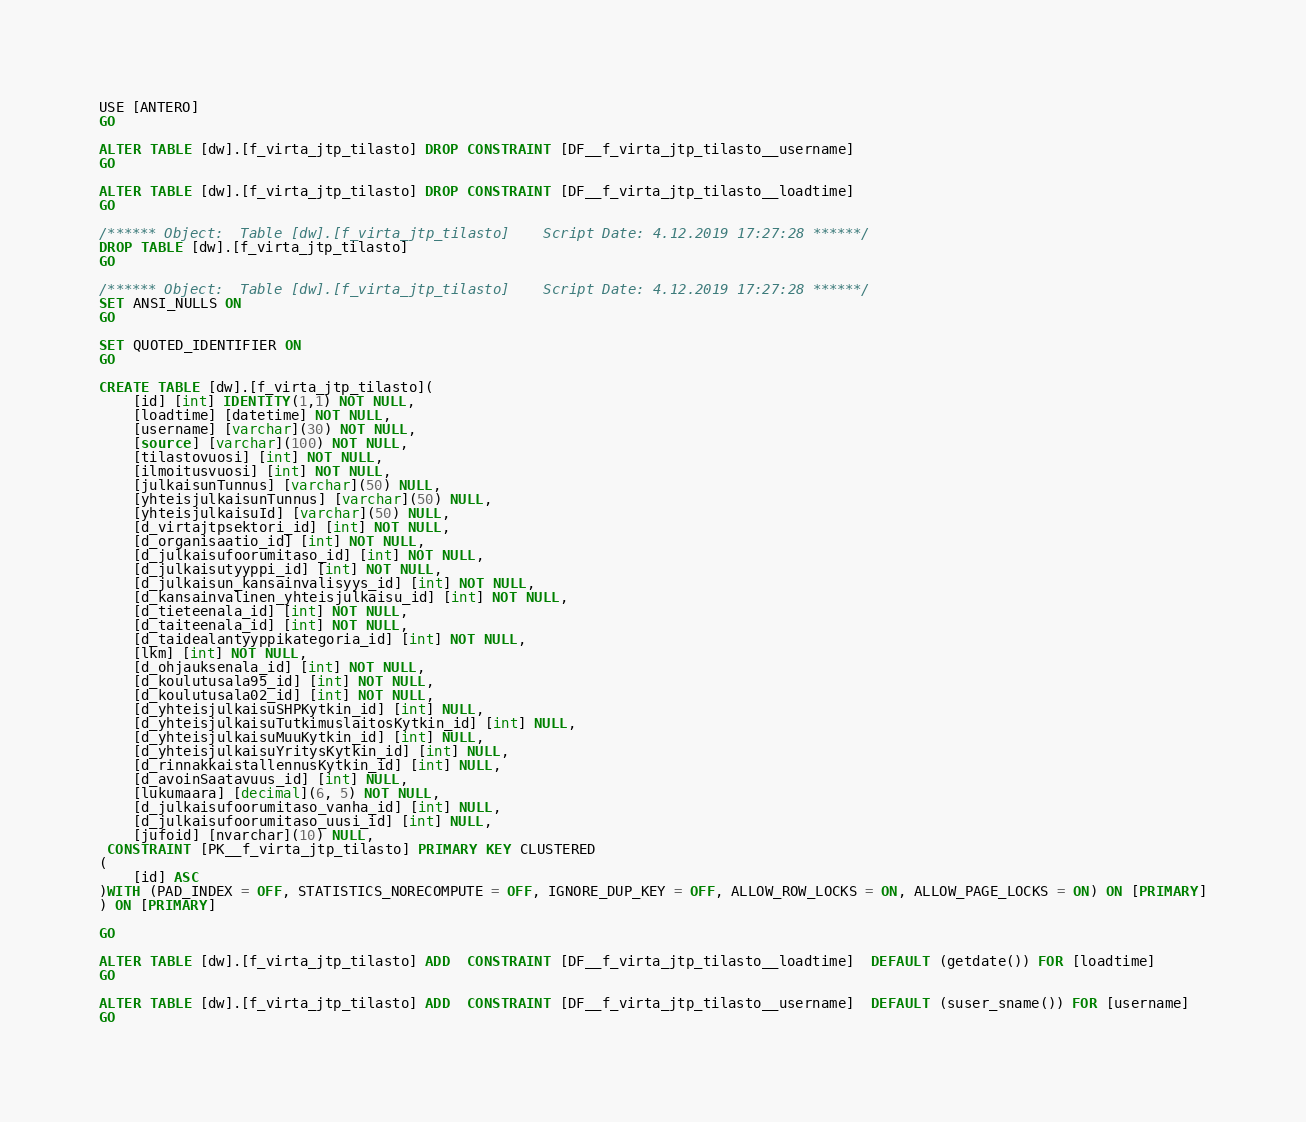<code> <loc_0><loc_0><loc_500><loc_500><_SQL_>USE [ANTERO]
GO

ALTER TABLE [dw].[f_virta_jtp_tilasto] DROP CONSTRAINT [DF__f_virta_jtp_tilasto__username]
GO

ALTER TABLE [dw].[f_virta_jtp_tilasto] DROP CONSTRAINT [DF__f_virta_jtp_tilasto__loadtime]
GO

/****** Object:  Table [dw].[f_virta_jtp_tilasto]    Script Date: 4.12.2019 17:27:28 ******/
DROP TABLE [dw].[f_virta_jtp_tilasto]
GO

/****** Object:  Table [dw].[f_virta_jtp_tilasto]    Script Date: 4.12.2019 17:27:28 ******/
SET ANSI_NULLS ON
GO

SET QUOTED_IDENTIFIER ON
GO

CREATE TABLE [dw].[f_virta_jtp_tilasto](
	[id] [int] IDENTITY(1,1) NOT NULL,
	[loadtime] [datetime] NOT NULL,
	[username] [varchar](30) NOT NULL,
	[source] [varchar](100) NOT NULL,
	[tilastovuosi] [int] NOT NULL,
	[ilmoitusvuosi] [int] NOT NULL,
	[julkaisunTunnus] [varchar](50) NULL,
	[yhteisjulkaisunTunnus] [varchar](50) NULL,
	[yhteisjulkaisuId] [varchar](50) NULL,
	[d_virtajtpsektori_id] [int] NOT NULL,
	[d_organisaatio_id] [int] NOT NULL,
	[d_julkaisufoorumitaso_id] [int] NOT NULL,
	[d_julkaisutyyppi_id] [int] NOT NULL,
	[d_julkaisun_kansainvalisyys_id] [int] NOT NULL,
	[d_kansainvalinen_yhteisjulkaisu_id] [int] NOT NULL,
	[d_tieteenala_id] [int] NOT NULL,
	[d_taiteenala_id] [int] NOT NULL,
	[d_taidealantyyppikategoria_id] [int] NOT NULL,
	[lkm] [int] NOT NULL,
	[d_ohjauksenala_id] [int] NOT NULL,
	[d_koulutusala95_id] [int] NOT NULL,
	[d_koulutusala02_id] [int] NOT NULL,
	[d_yhteisjulkaisuSHPKytkin_id] [int] NULL,
	[d_yhteisjulkaisuTutkimuslaitosKytkin_id] [int] NULL,
	[d_yhteisjulkaisuMuuKytkin_id] [int] NULL,
	[d_yhteisjulkaisuYritysKytkin_id] [int] NULL,
	[d_rinnakkaistallennusKytkin_id] [int] NULL,
	[d_avoinSaatavuus_id] [int] NULL,
	[lukumaara] [decimal](6, 5) NOT NULL,
	[d_julkaisufoorumitaso_vanha_id] [int] NULL,
	[d_julkaisufoorumitaso_uusi_id] [int] NULL,
	[jufoid] [nvarchar](10) NULL,
 CONSTRAINT [PK__f_virta_jtp_tilasto] PRIMARY KEY CLUSTERED 
(
	[id] ASC
)WITH (PAD_INDEX = OFF, STATISTICS_NORECOMPUTE = OFF, IGNORE_DUP_KEY = OFF, ALLOW_ROW_LOCKS = ON, ALLOW_PAGE_LOCKS = ON) ON [PRIMARY]
) ON [PRIMARY]

GO

ALTER TABLE [dw].[f_virta_jtp_tilasto] ADD  CONSTRAINT [DF__f_virta_jtp_tilasto__loadtime]  DEFAULT (getdate()) FOR [loadtime]
GO

ALTER TABLE [dw].[f_virta_jtp_tilasto] ADD  CONSTRAINT [DF__f_virta_jtp_tilasto__username]  DEFAULT (suser_sname()) FOR [username]
GO


</code> 